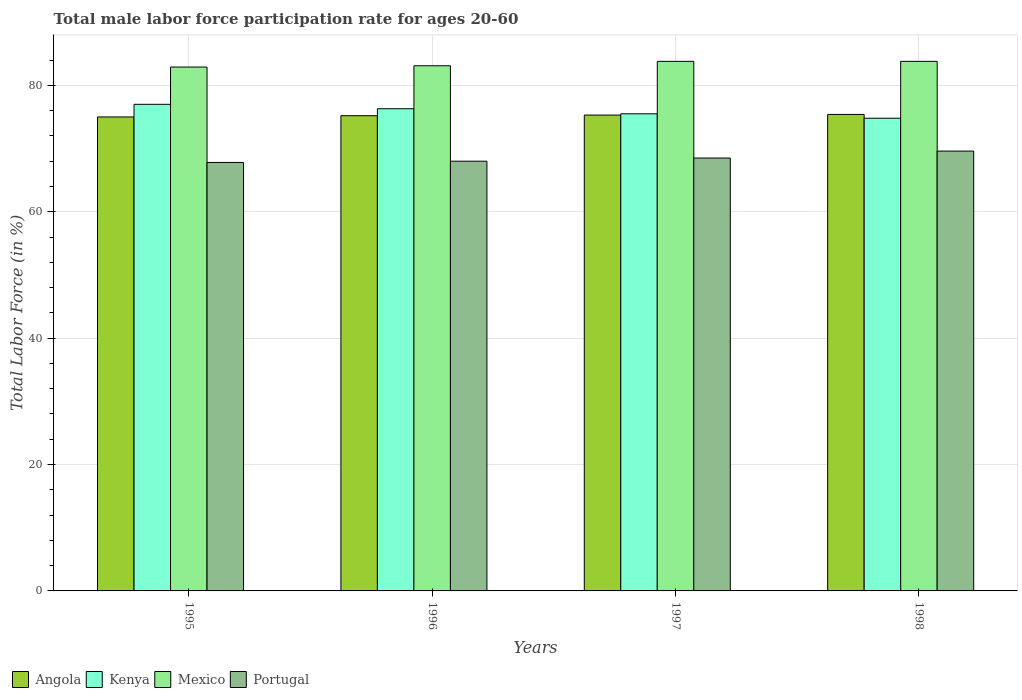How many different coloured bars are there?
Your answer should be compact. 4. Are the number of bars on each tick of the X-axis equal?
Your answer should be compact. Yes. How many bars are there on the 4th tick from the left?
Your response must be concise. 4. What is the label of the 3rd group of bars from the left?
Keep it short and to the point. 1997. In how many cases, is the number of bars for a given year not equal to the number of legend labels?
Provide a short and direct response. 0. What is the male labor force participation rate in Mexico in 1997?
Make the answer very short. 83.8. Across all years, what is the maximum male labor force participation rate in Angola?
Your answer should be compact. 75.4. Across all years, what is the minimum male labor force participation rate in Kenya?
Keep it short and to the point. 74.8. In which year was the male labor force participation rate in Kenya maximum?
Make the answer very short. 1995. What is the total male labor force participation rate in Portugal in the graph?
Your answer should be compact. 273.9. What is the difference between the male labor force participation rate in Mexico in 1996 and that in 1998?
Offer a terse response. -0.7. What is the difference between the male labor force participation rate in Kenya in 1996 and the male labor force participation rate in Mexico in 1995?
Ensure brevity in your answer.  -6.6. What is the average male labor force participation rate in Kenya per year?
Provide a short and direct response. 75.9. In the year 1996, what is the difference between the male labor force participation rate in Mexico and male labor force participation rate in Kenya?
Give a very brief answer. 6.8. In how many years, is the male labor force participation rate in Kenya greater than 64 %?
Make the answer very short. 4. What is the ratio of the male labor force participation rate in Kenya in 1995 to that in 1997?
Give a very brief answer. 1.02. Is the difference between the male labor force participation rate in Mexico in 1996 and 1997 greater than the difference between the male labor force participation rate in Kenya in 1996 and 1997?
Make the answer very short. No. What is the difference between the highest and the second highest male labor force participation rate in Mexico?
Your response must be concise. 0. What is the difference between the highest and the lowest male labor force participation rate in Angola?
Your answer should be very brief. 0.4. In how many years, is the male labor force participation rate in Kenya greater than the average male labor force participation rate in Kenya taken over all years?
Keep it short and to the point. 2. Is the sum of the male labor force participation rate in Portugal in 1995 and 1997 greater than the maximum male labor force participation rate in Mexico across all years?
Your response must be concise. Yes. What does the 1st bar from the left in 1996 represents?
Offer a terse response. Angola. What does the 1st bar from the right in 1996 represents?
Offer a terse response. Portugal. How many bars are there?
Offer a terse response. 16. Are all the bars in the graph horizontal?
Make the answer very short. No. What is the difference between two consecutive major ticks on the Y-axis?
Give a very brief answer. 20. Does the graph contain any zero values?
Give a very brief answer. No. Where does the legend appear in the graph?
Provide a succinct answer. Bottom left. What is the title of the graph?
Give a very brief answer. Total male labor force participation rate for ages 20-60. Does "China" appear as one of the legend labels in the graph?
Ensure brevity in your answer.  No. What is the Total Labor Force (in %) of Mexico in 1995?
Your response must be concise. 82.9. What is the Total Labor Force (in %) of Portugal in 1995?
Offer a very short reply. 67.8. What is the Total Labor Force (in %) of Angola in 1996?
Give a very brief answer. 75.2. What is the Total Labor Force (in %) in Kenya in 1996?
Ensure brevity in your answer.  76.3. What is the Total Labor Force (in %) of Mexico in 1996?
Ensure brevity in your answer.  83.1. What is the Total Labor Force (in %) in Portugal in 1996?
Your answer should be compact. 68. What is the Total Labor Force (in %) of Angola in 1997?
Your answer should be compact. 75.3. What is the Total Labor Force (in %) of Kenya in 1997?
Provide a succinct answer. 75.5. What is the Total Labor Force (in %) of Mexico in 1997?
Your answer should be compact. 83.8. What is the Total Labor Force (in %) of Portugal in 1997?
Offer a terse response. 68.5. What is the Total Labor Force (in %) of Angola in 1998?
Ensure brevity in your answer.  75.4. What is the Total Labor Force (in %) in Kenya in 1998?
Keep it short and to the point. 74.8. What is the Total Labor Force (in %) of Mexico in 1998?
Ensure brevity in your answer.  83.8. What is the Total Labor Force (in %) of Portugal in 1998?
Offer a very short reply. 69.6. Across all years, what is the maximum Total Labor Force (in %) in Angola?
Your answer should be very brief. 75.4. Across all years, what is the maximum Total Labor Force (in %) of Kenya?
Your answer should be very brief. 77. Across all years, what is the maximum Total Labor Force (in %) of Mexico?
Your answer should be very brief. 83.8. Across all years, what is the maximum Total Labor Force (in %) of Portugal?
Offer a terse response. 69.6. Across all years, what is the minimum Total Labor Force (in %) in Kenya?
Provide a short and direct response. 74.8. Across all years, what is the minimum Total Labor Force (in %) of Mexico?
Offer a very short reply. 82.9. Across all years, what is the minimum Total Labor Force (in %) in Portugal?
Provide a succinct answer. 67.8. What is the total Total Labor Force (in %) of Angola in the graph?
Provide a succinct answer. 300.9. What is the total Total Labor Force (in %) in Kenya in the graph?
Give a very brief answer. 303.6. What is the total Total Labor Force (in %) in Mexico in the graph?
Provide a succinct answer. 333.6. What is the total Total Labor Force (in %) of Portugal in the graph?
Provide a short and direct response. 273.9. What is the difference between the Total Labor Force (in %) of Mexico in 1995 and that in 1996?
Make the answer very short. -0.2. What is the difference between the Total Labor Force (in %) of Portugal in 1995 and that in 1996?
Ensure brevity in your answer.  -0.2. What is the difference between the Total Labor Force (in %) in Kenya in 1995 and that in 1997?
Your response must be concise. 1.5. What is the difference between the Total Labor Force (in %) of Portugal in 1995 and that in 1997?
Ensure brevity in your answer.  -0.7. What is the difference between the Total Labor Force (in %) in Kenya in 1995 and that in 1998?
Make the answer very short. 2.2. What is the difference between the Total Labor Force (in %) in Mexico in 1995 and that in 1998?
Ensure brevity in your answer.  -0.9. What is the difference between the Total Labor Force (in %) in Portugal in 1996 and that in 1997?
Ensure brevity in your answer.  -0.5. What is the difference between the Total Labor Force (in %) in Angola in 1996 and that in 1998?
Give a very brief answer. -0.2. What is the difference between the Total Labor Force (in %) of Kenya in 1996 and that in 1998?
Ensure brevity in your answer.  1.5. What is the difference between the Total Labor Force (in %) in Portugal in 1997 and that in 1998?
Your answer should be compact. -1.1. What is the difference between the Total Labor Force (in %) of Angola in 1995 and the Total Labor Force (in %) of Mexico in 1996?
Your response must be concise. -8.1. What is the difference between the Total Labor Force (in %) in Angola in 1995 and the Total Labor Force (in %) in Portugal in 1996?
Your response must be concise. 7. What is the difference between the Total Labor Force (in %) of Kenya in 1995 and the Total Labor Force (in %) of Mexico in 1996?
Ensure brevity in your answer.  -6.1. What is the difference between the Total Labor Force (in %) in Angola in 1995 and the Total Labor Force (in %) in Mexico in 1997?
Keep it short and to the point. -8.8. What is the difference between the Total Labor Force (in %) of Kenya in 1995 and the Total Labor Force (in %) of Mexico in 1997?
Your answer should be very brief. -6.8. What is the difference between the Total Labor Force (in %) of Kenya in 1995 and the Total Labor Force (in %) of Portugal in 1997?
Provide a short and direct response. 8.5. What is the difference between the Total Labor Force (in %) in Angola in 1995 and the Total Labor Force (in %) in Kenya in 1998?
Give a very brief answer. 0.2. What is the difference between the Total Labor Force (in %) in Angola in 1995 and the Total Labor Force (in %) in Mexico in 1998?
Provide a succinct answer. -8.8. What is the difference between the Total Labor Force (in %) in Angola in 1995 and the Total Labor Force (in %) in Portugal in 1998?
Your answer should be compact. 5.4. What is the difference between the Total Labor Force (in %) of Kenya in 1995 and the Total Labor Force (in %) of Portugal in 1998?
Your answer should be very brief. 7.4. What is the difference between the Total Labor Force (in %) in Angola in 1996 and the Total Labor Force (in %) in Kenya in 1997?
Your response must be concise. -0.3. What is the difference between the Total Labor Force (in %) of Angola in 1996 and the Total Labor Force (in %) of Mexico in 1997?
Your response must be concise. -8.6. What is the difference between the Total Labor Force (in %) of Kenya in 1996 and the Total Labor Force (in %) of Mexico in 1997?
Provide a short and direct response. -7.5. What is the difference between the Total Labor Force (in %) of Kenya in 1996 and the Total Labor Force (in %) of Portugal in 1997?
Make the answer very short. 7.8. What is the difference between the Total Labor Force (in %) of Mexico in 1996 and the Total Labor Force (in %) of Portugal in 1997?
Your answer should be very brief. 14.6. What is the difference between the Total Labor Force (in %) in Angola in 1996 and the Total Labor Force (in %) in Mexico in 1998?
Offer a very short reply. -8.6. What is the difference between the Total Labor Force (in %) in Angola in 1996 and the Total Labor Force (in %) in Portugal in 1998?
Provide a short and direct response. 5.6. What is the difference between the Total Labor Force (in %) in Kenya in 1996 and the Total Labor Force (in %) in Portugal in 1998?
Provide a succinct answer. 6.7. What is the difference between the Total Labor Force (in %) of Angola in 1997 and the Total Labor Force (in %) of Kenya in 1998?
Make the answer very short. 0.5. What is the difference between the Total Labor Force (in %) in Kenya in 1997 and the Total Labor Force (in %) in Mexico in 1998?
Your answer should be compact. -8.3. What is the difference between the Total Labor Force (in %) in Kenya in 1997 and the Total Labor Force (in %) in Portugal in 1998?
Offer a very short reply. 5.9. What is the difference between the Total Labor Force (in %) in Mexico in 1997 and the Total Labor Force (in %) in Portugal in 1998?
Give a very brief answer. 14.2. What is the average Total Labor Force (in %) of Angola per year?
Your response must be concise. 75.22. What is the average Total Labor Force (in %) of Kenya per year?
Make the answer very short. 75.9. What is the average Total Labor Force (in %) in Mexico per year?
Give a very brief answer. 83.4. What is the average Total Labor Force (in %) of Portugal per year?
Make the answer very short. 68.47. In the year 1995, what is the difference between the Total Labor Force (in %) in Angola and Total Labor Force (in %) in Kenya?
Offer a terse response. -2. In the year 1996, what is the difference between the Total Labor Force (in %) in Angola and Total Labor Force (in %) in Kenya?
Provide a succinct answer. -1.1. In the year 1996, what is the difference between the Total Labor Force (in %) of Kenya and Total Labor Force (in %) of Mexico?
Keep it short and to the point. -6.8. In the year 1997, what is the difference between the Total Labor Force (in %) in Angola and Total Labor Force (in %) in Kenya?
Offer a very short reply. -0.2. In the year 1997, what is the difference between the Total Labor Force (in %) in Angola and Total Labor Force (in %) in Mexico?
Provide a short and direct response. -8.5. In the year 1998, what is the difference between the Total Labor Force (in %) of Angola and Total Labor Force (in %) of Kenya?
Your response must be concise. 0.6. In the year 1998, what is the difference between the Total Labor Force (in %) in Angola and Total Labor Force (in %) in Mexico?
Your answer should be very brief. -8.4. In the year 1998, what is the difference between the Total Labor Force (in %) of Kenya and Total Labor Force (in %) of Mexico?
Ensure brevity in your answer.  -9. In the year 1998, what is the difference between the Total Labor Force (in %) of Mexico and Total Labor Force (in %) of Portugal?
Offer a terse response. 14.2. What is the ratio of the Total Labor Force (in %) of Angola in 1995 to that in 1996?
Give a very brief answer. 1. What is the ratio of the Total Labor Force (in %) in Kenya in 1995 to that in 1996?
Provide a succinct answer. 1.01. What is the ratio of the Total Labor Force (in %) in Portugal in 1995 to that in 1996?
Keep it short and to the point. 1. What is the ratio of the Total Labor Force (in %) in Angola in 1995 to that in 1997?
Your answer should be compact. 1. What is the ratio of the Total Labor Force (in %) in Kenya in 1995 to that in 1997?
Offer a very short reply. 1.02. What is the ratio of the Total Labor Force (in %) of Mexico in 1995 to that in 1997?
Keep it short and to the point. 0.99. What is the ratio of the Total Labor Force (in %) in Angola in 1995 to that in 1998?
Offer a terse response. 0.99. What is the ratio of the Total Labor Force (in %) in Kenya in 1995 to that in 1998?
Your answer should be very brief. 1.03. What is the ratio of the Total Labor Force (in %) in Mexico in 1995 to that in 1998?
Provide a short and direct response. 0.99. What is the ratio of the Total Labor Force (in %) of Portugal in 1995 to that in 1998?
Your response must be concise. 0.97. What is the ratio of the Total Labor Force (in %) of Angola in 1996 to that in 1997?
Keep it short and to the point. 1. What is the ratio of the Total Labor Force (in %) in Kenya in 1996 to that in 1997?
Provide a short and direct response. 1.01. What is the ratio of the Total Labor Force (in %) of Kenya in 1996 to that in 1998?
Your answer should be very brief. 1.02. What is the ratio of the Total Labor Force (in %) in Mexico in 1996 to that in 1998?
Provide a succinct answer. 0.99. What is the ratio of the Total Labor Force (in %) of Kenya in 1997 to that in 1998?
Provide a succinct answer. 1.01. What is the ratio of the Total Labor Force (in %) in Portugal in 1997 to that in 1998?
Your answer should be compact. 0.98. What is the difference between the highest and the second highest Total Labor Force (in %) of Angola?
Your response must be concise. 0.1. What is the difference between the highest and the second highest Total Labor Force (in %) of Kenya?
Provide a short and direct response. 0.7. What is the difference between the highest and the second highest Total Labor Force (in %) in Portugal?
Your response must be concise. 1.1. What is the difference between the highest and the lowest Total Labor Force (in %) of Angola?
Offer a terse response. 0.4. What is the difference between the highest and the lowest Total Labor Force (in %) of Kenya?
Ensure brevity in your answer.  2.2. What is the difference between the highest and the lowest Total Labor Force (in %) in Mexico?
Your response must be concise. 0.9. 